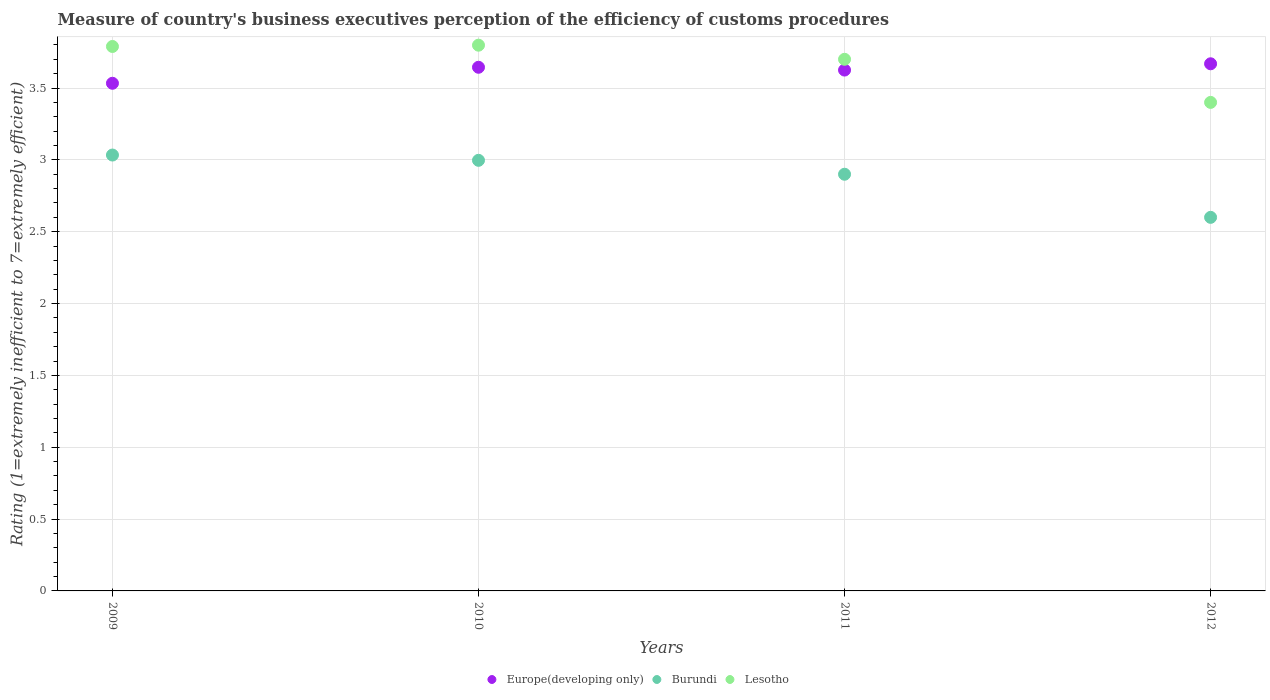How many different coloured dotlines are there?
Provide a short and direct response. 3. Is the number of dotlines equal to the number of legend labels?
Provide a short and direct response. Yes. What is the rating of the efficiency of customs procedure in Europe(developing only) in 2011?
Give a very brief answer. 3.62. Across all years, what is the maximum rating of the efficiency of customs procedure in Burundi?
Provide a succinct answer. 3.03. Across all years, what is the minimum rating of the efficiency of customs procedure in Europe(developing only)?
Give a very brief answer. 3.53. In which year was the rating of the efficiency of customs procedure in Burundi maximum?
Keep it short and to the point. 2009. In which year was the rating of the efficiency of customs procedure in Lesotho minimum?
Your answer should be compact. 2012. What is the total rating of the efficiency of customs procedure in Europe(developing only) in the graph?
Give a very brief answer. 14.47. What is the difference between the rating of the efficiency of customs procedure in Europe(developing only) in 2009 and that in 2010?
Offer a very short reply. -0.11. What is the difference between the rating of the efficiency of customs procedure in Lesotho in 2011 and the rating of the efficiency of customs procedure in Burundi in 2009?
Ensure brevity in your answer.  0.67. What is the average rating of the efficiency of customs procedure in Europe(developing only) per year?
Offer a terse response. 3.62. In the year 2010, what is the difference between the rating of the efficiency of customs procedure in Burundi and rating of the efficiency of customs procedure in Europe(developing only)?
Make the answer very short. -0.65. In how many years, is the rating of the efficiency of customs procedure in Lesotho greater than 0.1?
Make the answer very short. 4. What is the ratio of the rating of the efficiency of customs procedure in Burundi in 2010 to that in 2012?
Provide a short and direct response. 1.15. Is the rating of the efficiency of customs procedure in Lesotho in 2009 less than that in 2011?
Your response must be concise. No. Is the difference between the rating of the efficiency of customs procedure in Burundi in 2010 and 2011 greater than the difference between the rating of the efficiency of customs procedure in Europe(developing only) in 2010 and 2011?
Provide a succinct answer. Yes. What is the difference between the highest and the second highest rating of the efficiency of customs procedure in Burundi?
Provide a short and direct response. 0.04. What is the difference between the highest and the lowest rating of the efficiency of customs procedure in Lesotho?
Keep it short and to the point. 0.4. In how many years, is the rating of the efficiency of customs procedure in Europe(developing only) greater than the average rating of the efficiency of customs procedure in Europe(developing only) taken over all years?
Provide a short and direct response. 3. Does the rating of the efficiency of customs procedure in Europe(developing only) monotonically increase over the years?
Offer a terse response. No. How many dotlines are there?
Your answer should be compact. 3. How many years are there in the graph?
Make the answer very short. 4. What is the difference between two consecutive major ticks on the Y-axis?
Offer a very short reply. 0.5. Does the graph contain any zero values?
Offer a very short reply. No. Does the graph contain grids?
Your response must be concise. Yes. How many legend labels are there?
Offer a very short reply. 3. What is the title of the graph?
Offer a very short reply. Measure of country's business executives perception of the efficiency of customs procedures. Does "Guyana" appear as one of the legend labels in the graph?
Give a very brief answer. No. What is the label or title of the Y-axis?
Your answer should be very brief. Rating (1=extremely inefficient to 7=extremely efficient). What is the Rating (1=extremely inefficient to 7=extremely efficient) in Europe(developing only) in 2009?
Ensure brevity in your answer.  3.53. What is the Rating (1=extremely inefficient to 7=extremely efficient) in Burundi in 2009?
Keep it short and to the point. 3.03. What is the Rating (1=extremely inefficient to 7=extremely efficient) of Lesotho in 2009?
Provide a succinct answer. 3.79. What is the Rating (1=extremely inefficient to 7=extremely efficient) of Europe(developing only) in 2010?
Your response must be concise. 3.64. What is the Rating (1=extremely inefficient to 7=extremely efficient) of Burundi in 2010?
Offer a very short reply. 3. What is the Rating (1=extremely inefficient to 7=extremely efficient) of Lesotho in 2010?
Keep it short and to the point. 3.8. What is the Rating (1=extremely inefficient to 7=extremely efficient) of Europe(developing only) in 2011?
Offer a very short reply. 3.62. What is the Rating (1=extremely inefficient to 7=extremely efficient) of Europe(developing only) in 2012?
Your response must be concise. 3.67. What is the Rating (1=extremely inefficient to 7=extremely efficient) in Burundi in 2012?
Give a very brief answer. 2.6. Across all years, what is the maximum Rating (1=extremely inefficient to 7=extremely efficient) of Europe(developing only)?
Your answer should be compact. 3.67. Across all years, what is the maximum Rating (1=extremely inefficient to 7=extremely efficient) of Burundi?
Provide a succinct answer. 3.03. Across all years, what is the maximum Rating (1=extremely inefficient to 7=extremely efficient) of Lesotho?
Your response must be concise. 3.8. Across all years, what is the minimum Rating (1=extremely inefficient to 7=extremely efficient) in Europe(developing only)?
Your response must be concise. 3.53. What is the total Rating (1=extremely inefficient to 7=extremely efficient) of Europe(developing only) in the graph?
Ensure brevity in your answer.  14.47. What is the total Rating (1=extremely inefficient to 7=extremely efficient) in Burundi in the graph?
Offer a terse response. 11.53. What is the total Rating (1=extremely inefficient to 7=extremely efficient) in Lesotho in the graph?
Give a very brief answer. 14.69. What is the difference between the Rating (1=extremely inefficient to 7=extremely efficient) in Europe(developing only) in 2009 and that in 2010?
Offer a very short reply. -0.11. What is the difference between the Rating (1=extremely inefficient to 7=extremely efficient) of Burundi in 2009 and that in 2010?
Give a very brief answer. 0.04. What is the difference between the Rating (1=extremely inefficient to 7=extremely efficient) of Lesotho in 2009 and that in 2010?
Offer a very short reply. -0.01. What is the difference between the Rating (1=extremely inefficient to 7=extremely efficient) of Europe(developing only) in 2009 and that in 2011?
Provide a succinct answer. -0.09. What is the difference between the Rating (1=extremely inefficient to 7=extremely efficient) of Burundi in 2009 and that in 2011?
Give a very brief answer. 0.13. What is the difference between the Rating (1=extremely inefficient to 7=extremely efficient) in Lesotho in 2009 and that in 2011?
Provide a succinct answer. 0.09. What is the difference between the Rating (1=extremely inefficient to 7=extremely efficient) in Europe(developing only) in 2009 and that in 2012?
Offer a terse response. -0.14. What is the difference between the Rating (1=extremely inefficient to 7=extremely efficient) in Burundi in 2009 and that in 2012?
Keep it short and to the point. 0.43. What is the difference between the Rating (1=extremely inefficient to 7=extremely efficient) of Lesotho in 2009 and that in 2012?
Your answer should be very brief. 0.39. What is the difference between the Rating (1=extremely inefficient to 7=extremely efficient) of Europe(developing only) in 2010 and that in 2011?
Your response must be concise. 0.02. What is the difference between the Rating (1=extremely inefficient to 7=extremely efficient) of Burundi in 2010 and that in 2011?
Provide a short and direct response. 0.1. What is the difference between the Rating (1=extremely inefficient to 7=extremely efficient) in Lesotho in 2010 and that in 2011?
Your answer should be very brief. 0.1. What is the difference between the Rating (1=extremely inefficient to 7=extremely efficient) in Europe(developing only) in 2010 and that in 2012?
Provide a short and direct response. -0.02. What is the difference between the Rating (1=extremely inefficient to 7=extremely efficient) of Burundi in 2010 and that in 2012?
Make the answer very short. 0.4. What is the difference between the Rating (1=extremely inefficient to 7=extremely efficient) in Lesotho in 2010 and that in 2012?
Give a very brief answer. 0.4. What is the difference between the Rating (1=extremely inefficient to 7=extremely efficient) of Europe(developing only) in 2011 and that in 2012?
Ensure brevity in your answer.  -0.04. What is the difference between the Rating (1=extremely inefficient to 7=extremely efficient) in Europe(developing only) in 2009 and the Rating (1=extremely inefficient to 7=extremely efficient) in Burundi in 2010?
Make the answer very short. 0.54. What is the difference between the Rating (1=extremely inefficient to 7=extremely efficient) in Europe(developing only) in 2009 and the Rating (1=extremely inefficient to 7=extremely efficient) in Lesotho in 2010?
Your response must be concise. -0.27. What is the difference between the Rating (1=extremely inefficient to 7=extremely efficient) in Burundi in 2009 and the Rating (1=extremely inefficient to 7=extremely efficient) in Lesotho in 2010?
Your answer should be compact. -0.76. What is the difference between the Rating (1=extremely inefficient to 7=extremely efficient) in Europe(developing only) in 2009 and the Rating (1=extremely inefficient to 7=extremely efficient) in Burundi in 2011?
Offer a very short reply. 0.63. What is the difference between the Rating (1=extremely inefficient to 7=extremely efficient) of Europe(developing only) in 2009 and the Rating (1=extremely inefficient to 7=extremely efficient) of Lesotho in 2011?
Offer a terse response. -0.17. What is the difference between the Rating (1=extremely inefficient to 7=extremely efficient) of Burundi in 2009 and the Rating (1=extremely inefficient to 7=extremely efficient) of Lesotho in 2011?
Your answer should be compact. -0.67. What is the difference between the Rating (1=extremely inefficient to 7=extremely efficient) of Europe(developing only) in 2009 and the Rating (1=extremely inefficient to 7=extremely efficient) of Burundi in 2012?
Your answer should be compact. 0.93. What is the difference between the Rating (1=extremely inefficient to 7=extremely efficient) in Europe(developing only) in 2009 and the Rating (1=extremely inefficient to 7=extremely efficient) in Lesotho in 2012?
Ensure brevity in your answer.  0.13. What is the difference between the Rating (1=extremely inefficient to 7=extremely efficient) in Burundi in 2009 and the Rating (1=extremely inefficient to 7=extremely efficient) in Lesotho in 2012?
Provide a succinct answer. -0.37. What is the difference between the Rating (1=extremely inefficient to 7=extremely efficient) of Europe(developing only) in 2010 and the Rating (1=extremely inefficient to 7=extremely efficient) of Burundi in 2011?
Your answer should be very brief. 0.74. What is the difference between the Rating (1=extremely inefficient to 7=extremely efficient) in Europe(developing only) in 2010 and the Rating (1=extremely inefficient to 7=extremely efficient) in Lesotho in 2011?
Make the answer very short. -0.06. What is the difference between the Rating (1=extremely inefficient to 7=extremely efficient) of Burundi in 2010 and the Rating (1=extremely inefficient to 7=extremely efficient) of Lesotho in 2011?
Provide a succinct answer. -0.7. What is the difference between the Rating (1=extremely inefficient to 7=extremely efficient) in Europe(developing only) in 2010 and the Rating (1=extremely inefficient to 7=extremely efficient) in Burundi in 2012?
Your answer should be very brief. 1.04. What is the difference between the Rating (1=extremely inefficient to 7=extremely efficient) of Europe(developing only) in 2010 and the Rating (1=extremely inefficient to 7=extremely efficient) of Lesotho in 2012?
Provide a short and direct response. 0.24. What is the difference between the Rating (1=extremely inefficient to 7=extremely efficient) in Burundi in 2010 and the Rating (1=extremely inefficient to 7=extremely efficient) in Lesotho in 2012?
Give a very brief answer. -0.4. What is the difference between the Rating (1=extremely inefficient to 7=extremely efficient) of Europe(developing only) in 2011 and the Rating (1=extremely inefficient to 7=extremely efficient) of Lesotho in 2012?
Provide a succinct answer. 0.23. What is the difference between the Rating (1=extremely inefficient to 7=extremely efficient) in Burundi in 2011 and the Rating (1=extremely inefficient to 7=extremely efficient) in Lesotho in 2012?
Keep it short and to the point. -0.5. What is the average Rating (1=extremely inefficient to 7=extremely efficient) in Europe(developing only) per year?
Offer a very short reply. 3.62. What is the average Rating (1=extremely inefficient to 7=extremely efficient) of Burundi per year?
Your answer should be very brief. 2.88. What is the average Rating (1=extremely inefficient to 7=extremely efficient) of Lesotho per year?
Your answer should be very brief. 3.67. In the year 2009, what is the difference between the Rating (1=extremely inefficient to 7=extremely efficient) of Europe(developing only) and Rating (1=extremely inefficient to 7=extremely efficient) of Burundi?
Offer a very short reply. 0.5. In the year 2009, what is the difference between the Rating (1=extremely inefficient to 7=extremely efficient) of Europe(developing only) and Rating (1=extremely inefficient to 7=extremely efficient) of Lesotho?
Your answer should be very brief. -0.26. In the year 2009, what is the difference between the Rating (1=extremely inefficient to 7=extremely efficient) in Burundi and Rating (1=extremely inefficient to 7=extremely efficient) in Lesotho?
Your response must be concise. -0.76. In the year 2010, what is the difference between the Rating (1=extremely inefficient to 7=extremely efficient) in Europe(developing only) and Rating (1=extremely inefficient to 7=extremely efficient) in Burundi?
Your answer should be compact. 0.65. In the year 2010, what is the difference between the Rating (1=extremely inefficient to 7=extremely efficient) of Europe(developing only) and Rating (1=extremely inefficient to 7=extremely efficient) of Lesotho?
Make the answer very short. -0.15. In the year 2010, what is the difference between the Rating (1=extremely inefficient to 7=extremely efficient) of Burundi and Rating (1=extremely inefficient to 7=extremely efficient) of Lesotho?
Offer a very short reply. -0.8. In the year 2011, what is the difference between the Rating (1=extremely inefficient to 7=extremely efficient) in Europe(developing only) and Rating (1=extremely inefficient to 7=extremely efficient) in Burundi?
Give a very brief answer. 0.72. In the year 2011, what is the difference between the Rating (1=extremely inefficient to 7=extremely efficient) in Europe(developing only) and Rating (1=extremely inefficient to 7=extremely efficient) in Lesotho?
Make the answer very short. -0.07. In the year 2011, what is the difference between the Rating (1=extremely inefficient to 7=extremely efficient) in Burundi and Rating (1=extremely inefficient to 7=extremely efficient) in Lesotho?
Give a very brief answer. -0.8. In the year 2012, what is the difference between the Rating (1=extremely inefficient to 7=extremely efficient) of Europe(developing only) and Rating (1=extremely inefficient to 7=extremely efficient) of Burundi?
Offer a terse response. 1.07. In the year 2012, what is the difference between the Rating (1=extremely inefficient to 7=extremely efficient) of Europe(developing only) and Rating (1=extremely inefficient to 7=extremely efficient) of Lesotho?
Provide a short and direct response. 0.27. What is the ratio of the Rating (1=extremely inefficient to 7=extremely efficient) in Europe(developing only) in 2009 to that in 2010?
Offer a terse response. 0.97. What is the ratio of the Rating (1=extremely inefficient to 7=extremely efficient) of Burundi in 2009 to that in 2010?
Provide a succinct answer. 1.01. What is the ratio of the Rating (1=extremely inefficient to 7=extremely efficient) in Europe(developing only) in 2009 to that in 2011?
Provide a short and direct response. 0.97. What is the ratio of the Rating (1=extremely inefficient to 7=extremely efficient) of Burundi in 2009 to that in 2011?
Your response must be concise. 1.05. What is the ratio of the Rating (1=extremely inefficient to 7=extremely efficient) of Lesotho in 2009 to that in 2011?
Your answer should be very brief. 1.02. What is the ratio of the Rating (1=extremely inefficient to 7=extremely efficient) of Burundi in 2009 to that in 2012?
Make the answer very short. 1.17. What is the ratio of the Rating (1=extremely inefficient to 7=extremely efficient) of Lesotho in 2009 to that in 2012?
Provide a succinct answer. 1.11. What is the ratio of the Rating (1=extremely inefficient to 7=extremely efficient) of Europe(developing only) in 2010 to that in 2011?
Your answer should be very brief. 1.01. What is the ratio of the Rating (1=extremely inefficient to 7=extremely efficient) of Burundi in 2010 to that in 2011?
Provide a succinct answer. 1.03. What is the ratio of the Rating (1=extremely inefficient to 7=extremely efficient) of Lesotho in 2010 to that in 2011?
Provide a succinct answer. 1.03. What is the ratio of the Rating (1=extremely inefficient to 7=extremely efficient) in Burundi in 2010 to that in 2012?
Provide a short and direct response. 1.15. What is the ratio of the Rating (1=extremely inefficient to 7=extremely efficient) in Lesotho in 2010 to that in 2012?
Offer a very short reply. 1.12. What is the ratio of the Rating (1=extremely inefficient to 7=extremely efficient) in Burundi in 2011 to that in 2012?
Your answer should be very brief. 1.12. What is the ratio of the Rating (1=extremely inefficient to 7=extremely efficient) in Lesotho in 2011 to that in 2012?
Give a very brief answer. 1.09. What is the difference between the highest and the second highest Rating (1=extremely inefficient to 7=extremely efficient) of Europe(developing only)?
Make the answer very short. 0.02. What is the difference between the highest and the second highest Rating (1=extremely inefficient to 7=extremely efficient) of Burundi?
Your answer should be very brief. 0.04. What is the difference between the highest and the second highest Rating (1=extremely inefficient to 7=extremely efficient) in Lesotho?
Make the answer very short. 0.01. What is the difference between the highest and the lowest Rating (1=extremely inefficient to 7=extremely efficient) in Europe(developing only)?
Offer a terse response. 0.14. What is the difference between the highest and the lowest Rating (1=extremely inefficient to 7=extremely efficient) of Burundi?
Provide a short and direct response. 0.43. What is the difference between the highest and the lowest Rating (1=extremely inefficient to 7=extremely efficient) in Lesotho?
Provide a succinct answer. 0.4. 